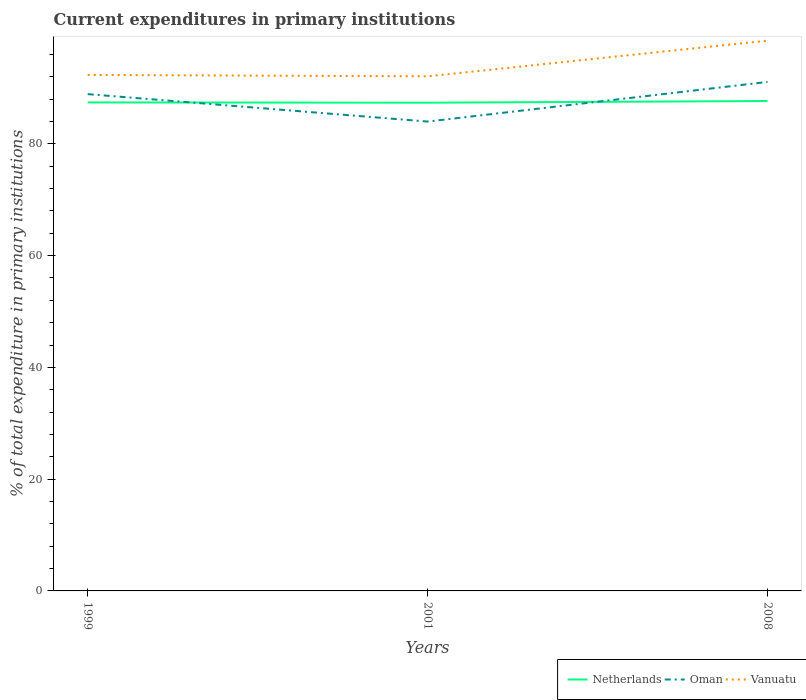Does the line corresponding to Vanuatu intersect with the line corresponding to Netherlands?
Provide a short and direct response. No. Across all years, what is the maximum current expenditures in primary institutions in Netherlands?
Give a very brief answer. 87.36. In which year was the current expenditures in primary institutions in Vanuatu maximum?
Offer a terse response. 2001. What is the total current expenditures in primary institutions in Vanuatu in the graph?
Offer a very short reply. -6.39. What is the difference between the highest and the second highest current expenditures in primary institutions in Vanuatu?
Provide a short and direct response. 6.39. How many years are there in the graph?
Make the answer very short. 3. What is the difference between two consecutive major ticks on the Y-axis?
Provide a short and direct response. 20. Are the values on the major ticks of Y-axis written in scientific E-notation?
Keep it short and to the point. No. Does the graph contain any zero values?
Make the answer very short. No. Does the graph contain grids?
Provide a succinct answer. No. How many legend labels are there?
Your answer should be very brief. 3. What is the title of the graph?
Make the answer very short. Current expenditures in primary institutions. What is the label or title of the Y-axis?
Provide a succinct answer. % of total expenditure in primary institutions. What is the % of total expenditure in primary institutions of Netherlands in 1999?
Provide a succinct answer. 87.41. What is the % of total expenditure in primary institutions in Oman in 1999?
Offer a very short reply. 88.9. What is the % of total expenditure in primary institutions of Vanuatu in 1999?
Give a very brief answer. 92.33. What is the % of total expenditure in primary institutions in Netherlands in 2001?
Make the answer very short. 87.36. What is the % of total expenditure in primary institutions in Oman in 2001?
Ensure brevity in your answer.  83.99. What is the % of total expenditure in primary institutions of Vanuatu in 2001?
Provide a succinct answer. 92.09. What is the % of total expenditure in primary institutions of Netherlands in 2008?
Your response must be concise. 87.67. What is the % of total expenditure in primary institutions of Oman in 2008?
Your answer should be compact. 91.08. What is the % of total expenditure in primary institutions of Vanuatu in 2008?
Give a very brief answer. 98.47. Across all years, what is the maximum % of total expenditure in primary institutions in Netherlands?
Your answer should be very brief. 87.67. Across all years, what is the maximum % of total expenditure in primary institutions of Oman?
Offer a very short reply. 91.08. Across all years, what is the maximum % of total expenditure in primary institutions in Vanuatu?
Your answer should be very brief. 98.47. Across all years, what is the minimum % of total expenditure in primary institutions of Netherlands?
Your answer should be very brief. 87.36. Across all years, what is the minimum % of total expenditure in primary institutions in Oman?
Ensure brevity in your answer.  83.99. Across all years, what is the minimum % of total expenditure in primary institutions in Vanuatu?
Your response must be concise. 92.09. What is the total % of total expenditure in primary institutions of Netherlands in the graph?
Make the answer very short. 262.44. What is the total % of total expenditure in primary institutions of Oman in the graph?
Provide a succinct answer. 263.97. What is the total % of total expenditure in primary institutions of Vanuatu in the graph?
Make the answer very short. 282.89. What is the difference between the % of total expenditure in primary institutions in Netherlands in 1999 and that in 2001?
Your response must be concise. 0.05. What is the difference between the % of total expenditure in primary institutions in Oman in 1999 and that in 2001?
Ensure brevity in your answer.  4.91. What is the difference between the % of total expenditure in primary institutions in Vanuatu in 1999 and that in 2001?
Make the answer very short. 0.24. What is the difference between the % of total expenditure in primary institutions of Netherlands in 1999 and that in 2008?
Offer a terse response. -0.25. What is the difference between the % of total expenditure in primary institutions in Oman in 1999 and that in 2008?
Provide a short and direct response. -2.18. What is the difference between the % of total expenditure in primary institutions in Vanuatu in 1999 and that in 2008?
Provide a succinct answer. -6.14. What is the difference between the % of total expenditure in primary institutions in Netherlands in 2001 and that in 2008?
Your answer should be compact. -0.3. What is the difference between the % of total expenditure in primary institutions of Oman in 2001 and that in 2008?
Keep it short and to the point. -7.1. What is the difference between the % of total expenditure in primary institutions in Vanuatu in 2001 and that in 2008?
Your response must be concise. -6.39. What is the difference between the % of total expenditure in primary institutions of Netherlands in 1999 and the % of total expenditure in primary institutions of Oman in 2001?
Offer a very short reply. 3.43. What is the difference between the % of total expenditure in primary institutions of Netherlands in 1999 and the % of total expenditure in primary institutions of Vanuatu in 2001?
Keep it short and to the point. -4.67. What is the difference between the % of total expenditure in primary institutions in Oman in 1999 and the % of total expenditure in primary institutions in Vanuatu in 2001?
Your answer should be very brief. -3.19. What is the difference between the % of total expenditure in primary institutions of Netherlands in 1999 and the % of total expenditure in primary institutions of Oman in 2008?
Provide a short and direct response. -3.67. What is the difference between the % of total expenditure in primary institutions of Netherlands in 1999 and the % of total expenditure in primary institutions of Vanuatu in 2008?
Your response must be concise. -11.06. What is the difference between the % of total expenditure in primary institutions of Oman in 1999 and the % of total expenditure in primary institutions of Vanuatu in 2008?
Offer a terse response. -9.57. What is the difference between the % of total expenditure in primary institutions of Netherlands in 2001 and the % of total expenditure in primary institutions of Oman in 2008?
Ensure brevity in your answer.  -3.72. What is the difference between the % of total expenditure in primary institutions of Netherlands in 2001 and the % of total expenditure in primary institutions of Vanuatu in 2008?
Your answer should be very brief. -11.11. What is the difference between the % of total expenditure in primary institutions of Oman in 2001 and the % of total expenditure in primary institutions of Vanuatu in 2008?
Offer a terse response. -14.48. What is the average % of total expenditure in primary institutions in Netherlands per year?
Provide a short and direct response. 87.48. What is the average % of total expenditure in primary institutions in Oman per year?
Give a very brief answer. 87.99. What is the average % of total expenditure in primary institutions of Vanuatu per year?
Ensure brevity in your answer.  94.3. In the year 1999, what is the difference between the % of total expenditure in primary institutions of Netherlands and % of total expenditure in primary institutions of Oman?
Your response must be concise. -1.48. In the year 1999, what is the difference between the % of total expenditure in primary institutions of Netherlands and % of total expenditure in primary institutions of Vanuatu?
Give a very brief answer. -4.92. In the year 1999, what is the difference between the % of total expenditure in primary institutions of Oman and % of total expenditure in primary institutions of Vanuatu?
Give a very brief answer. -3.43. In the year 2001, what is the difference between the % of total expenditure in primary institutions in Netherlands and % of total expenditure in primary institutions in Oman?
Ensure brevity in your answer.  3.38. In the year 2001, what is the difference between the % of total expenditure in primary institutions in Netherlands and % of total expenditure in primary institutions in Vanuatu?
Make the answer very short. -4.72. In the year 2001, what is the difference between the % of total expenditure in primary institutions in Oman and % of total expenditure in primary institutions in Vanuatu?
Your answer should be very brief. -8.1. In the year 2008, what is the difference between the % of total expenditure in primary institutions in Netherlands and % of total expenditure in primary institutions in Oman?
Offer a very short reply. -3.42. In the year 2008, what is the difference between the % of total expenditure in primary institutions in Netherlands and % of total expenditure in primary institutions in Vanuatu?
Your answer should be compact. -10.81. In the year 2008, what is the difference between the % of total expenditure in primary institutions in Oman and % of total expenditure in primary institutions in Vanuatu?
Ensure brevity in your answer.  -7.39. What is the ratio of the % of total expenditure in primary institutions of Netherlands in 1999 to that in 2001?
Your answer should be compact. 1. What is the ratio of the % of total expenditure in primary institutions in Oman in 1999 to that in 2001?
Make the answer very short. 1.06. What is the ratio of the % of total expenditure in primary institutions of Oman in 1999 to that in 2008?
Give a very brief answer. 0.98. What is the ratio of the % of total expenditure in primary institutions of Vanuatu in 1999 to that in 2008?
Give a very brief answer. 0.94. What is the ratio of the % of total expenditure in primary institutions in Netherlands in 2001 to that in 2008?
Your response must be concise. 1. What is the ratio of the % of total expenditure in primary institutions of Oman in 2001 to that in 2008?
Provide a short and direct response. 0.92. What is the ratio of the % of total expenditure in primary institutions in Vanuatu in 2001 to that in 2008?
Give a very brief answer. 0.94. What is the difference between the highest and the second highest % of total expenditure in primary institutions of Netherlands?
Offer a very short reply. 0.25. What is the difference between the highest and the second highest % of total expenditure in primary institutions in Oman?
Offer a terse response. 2.18. What is the difference between the highest and the second highest % of total expenditure in primary institutions of Vanuatu?
Your answer should be very brief. 6.14. What is the difference between the highest and the lowest % of total expenditure in primary institutions in Netherlands?
Give a very brief answer. 0.3. What is the difference between the highest and the lowest % of total expenditure in primary institutions in Oman?
Ensure brevity in your answer.  7.1. What is the difference between the highest and the lowest % of total expenditure in primary institutions of Vanuatu?
Provide a short and direct response. 6.39. 